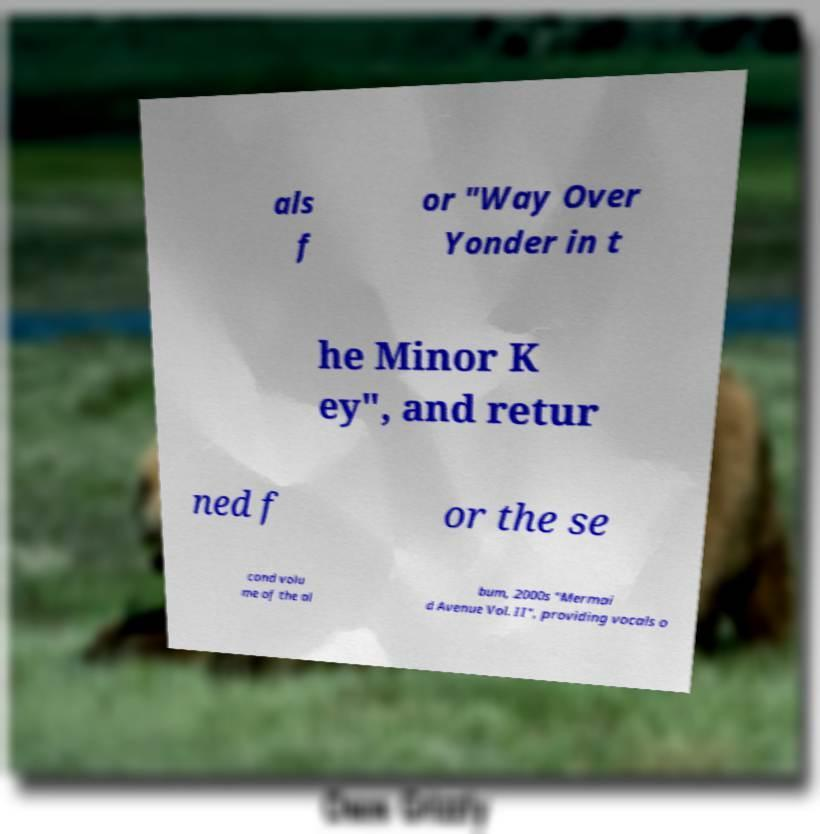What messages or text are displayed in this image? I need them in a readable, typed format. als f or "Way Over Yonder in t he Minor K ey", and retur ned f or the se cond volu me of the al bum, 2000s "Mermai d Avenue Vol. II", providing vocals o 